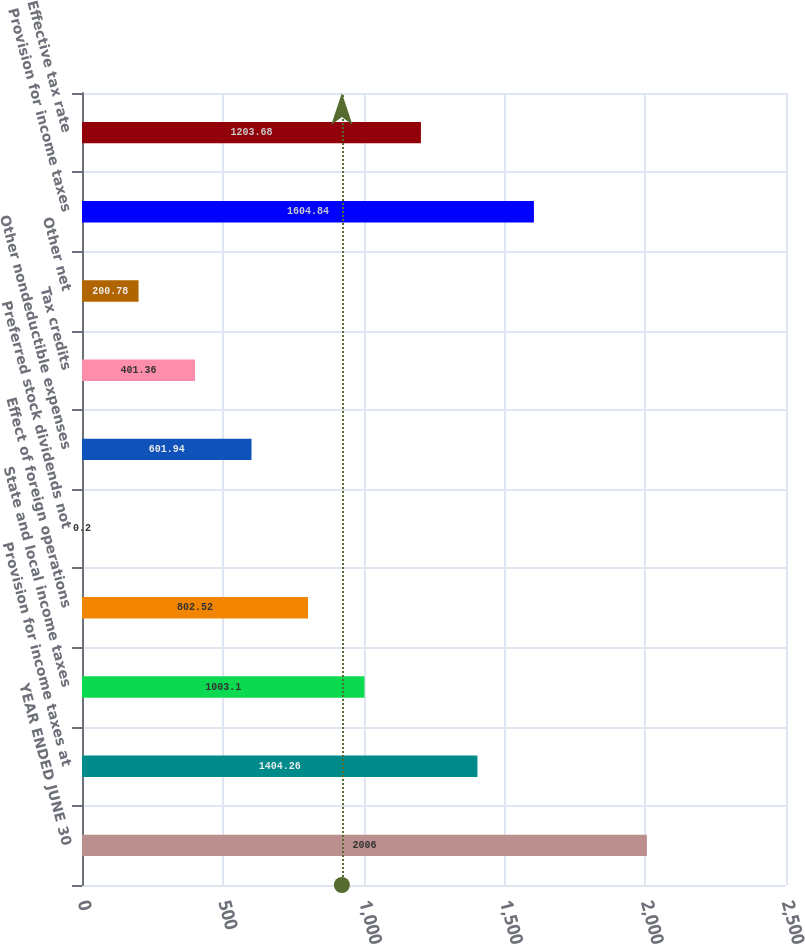Convert chart. <chart><loc_0><loc_0><loc_500><loc_500><bar_chart><fcel>YEAR ENDED JUNE 30<fcel>Provision for income taxes at<fcel>State and local income taxes<fcel>Effect of foreign operations<fcel>Preferred stock dividends not<fcel>Other nondeductible expenses<fcel>Tax credits<fcel>Other net<fcel>Provision for income taxes<fcel>Effective tax rate<nl><fcel>2006<fcel>1404.26<fcel>1003.1<fcel>802.52<fcel>0.2<fcel>601.94<fcel>401.36<fcel>200.78<fcel>1604.84<fcel>1203.68<nl></chart> 